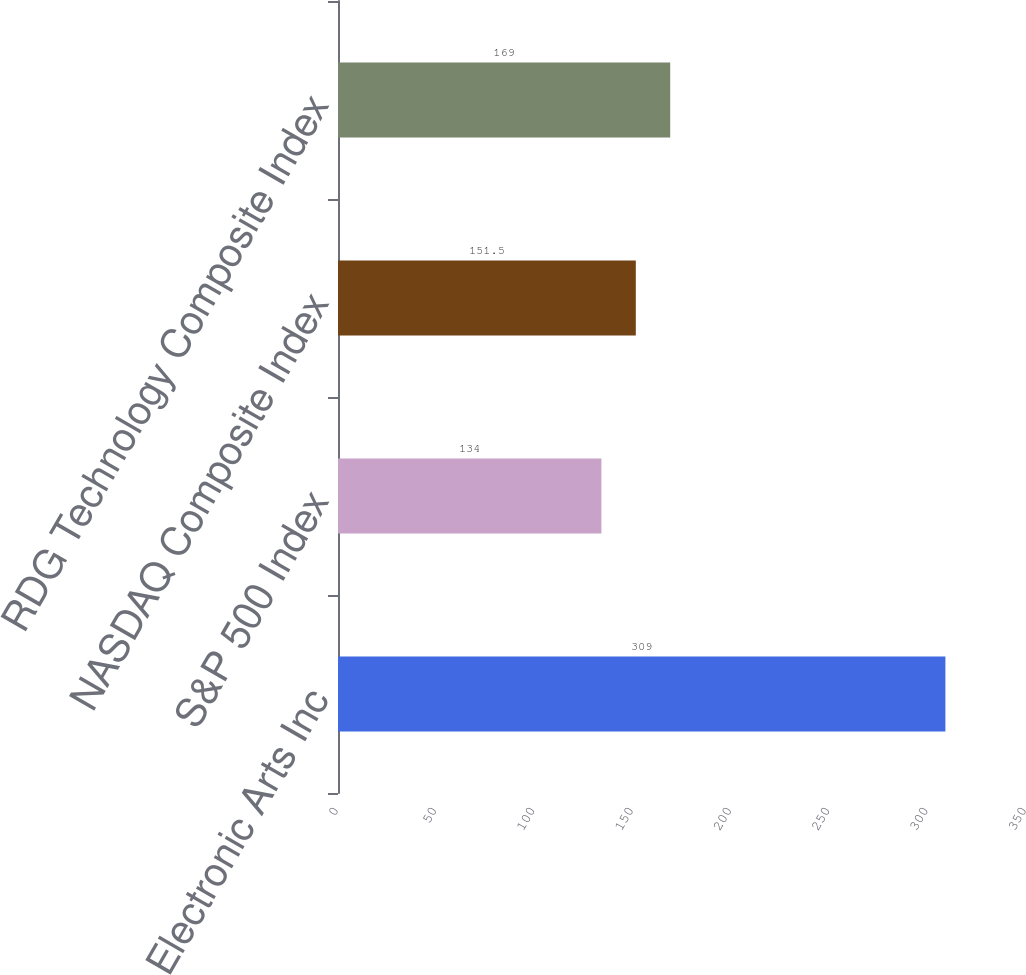<chart> <loc_0><loc_0><loc_500><loc_500><bar_chart><fcel>Electronic Arts Inc<fcel>S&P 500 Index<fcel>NASDAQ Composite Index<fcel>RDG Technology Composite Index<nl><fcel>309<fcel>134<fcel>151.5<fcel>169<nl></chart> 